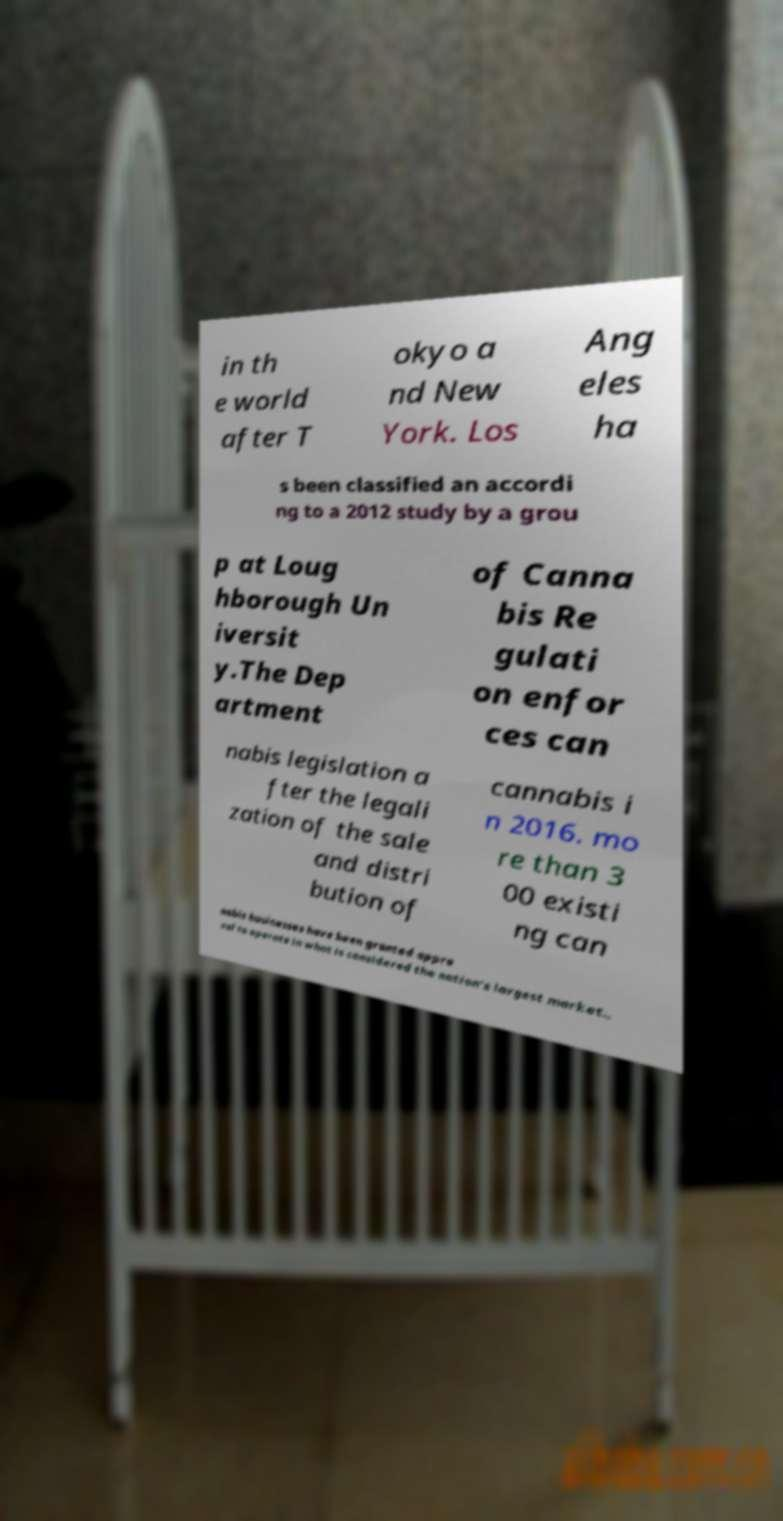There's text embedded in this image that I need extracted. Can you transcribe it verbatim? in th e world after T okyo a nd New York. Los Ang eles ha s been classified an accordi ng to a 2012 study by a grou p at Loug hborough Un iversit y.The Dep artment of Canna bis Re gulati on enfor ces can nabis legislation a fter the legali zation of the sale and distri bution of cannabis i n 2016. mo re than 3 00 existi ng can nabis businesses have been granted appro val to operate in what is considered the nation's largest market., 